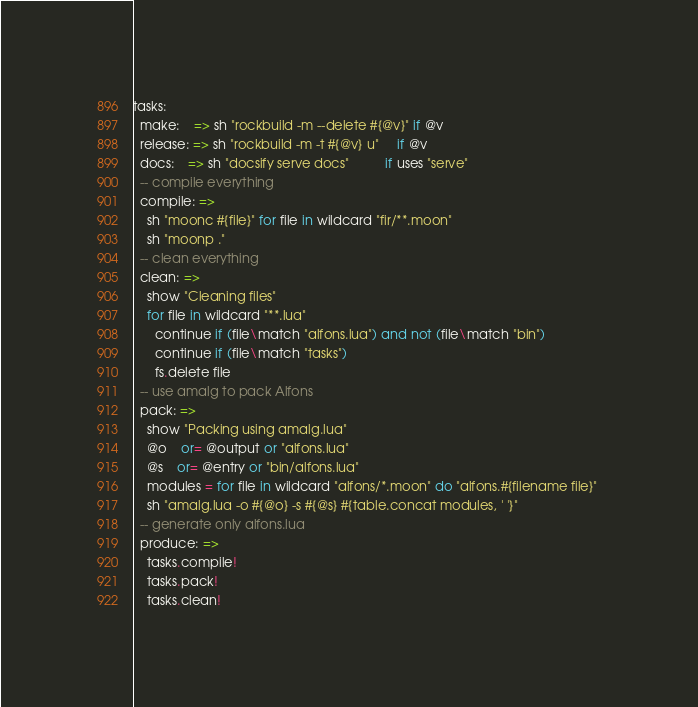<code> <loc_0><loc_0><loc_500><loc_500><_MoonScript_>tasks:
  make:    => sh "rockbuild -m --delete #{@v}" if @v
  release: => sh "rockbuild -m -t #{@v} u"     if @v
  docs:    => sh "docsify serve docs"          if uses "serve"
  -- compile everything
  compile: =>
    sh "moonc #{file}" for file in wildcard "fir/**.moon"
    sh "moonp ."
  -- clean everything
  clean: =>
    show "Cleaning files"
    for file in wildcard "**.lua"
      continue if (file\match "alfons.lua") and not (file\match "bin")
      continue if (file\match "tasks")
      fs.delete file
  -- use amalg to pack Alfons
  pack: =>
    show "Packing using amalg.lua"
    @o    or= @output or "alfons.lua"
    @s    or= @entry or "bin/alfons.lua"
    modules = for file in wildcard "alfons/*.moon" do "alfons.#{filename file}" 
    sh "amalg.lua -o #{@o} -s #{@s} #{table.concat modules, ' '}"
  -- generate only alfons.lua
  produce: =>
    tasks.compile!
    tasks.pack!
    tasks.clean!</code> 